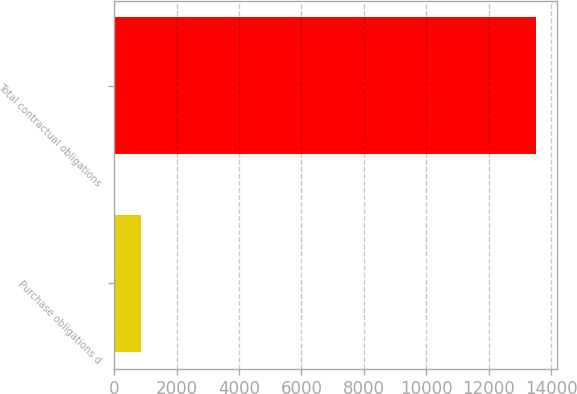Convert chart. <chart><loc_0><loc_0><loc_500><loc_500><bar_chart><fcel>Purchase obligations d<fcel>Total contractual obligations<nl><fcel>858<fcel>13508<nl></chart> 